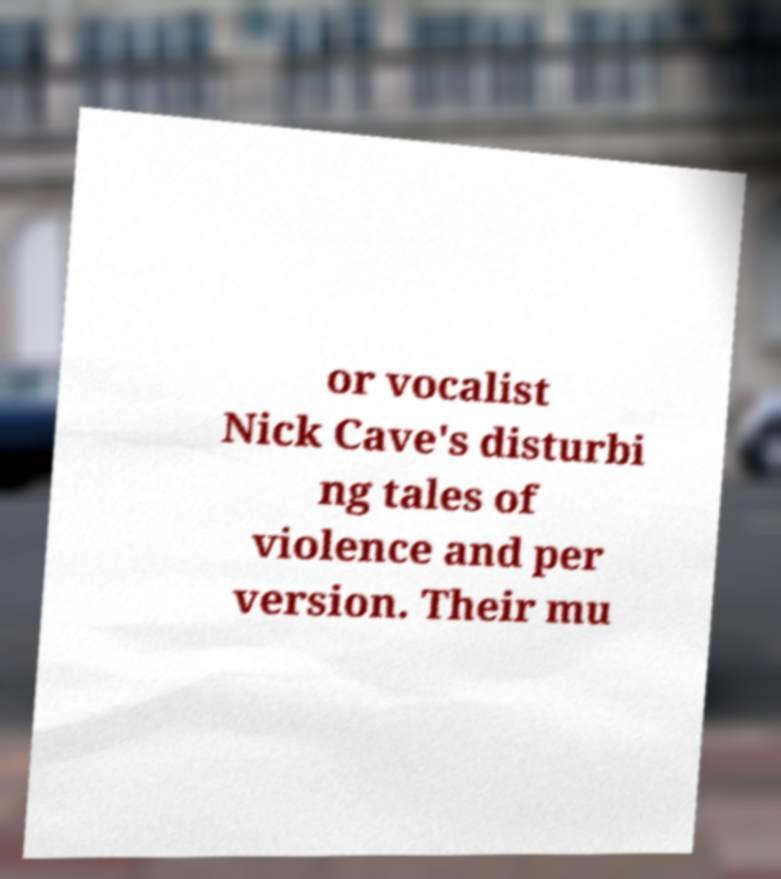What messages or text are displayed in this image? I need them in a readable, typed format. or vocalist Nick Cave's disturbi ng tales of violence and per version. Their mu 